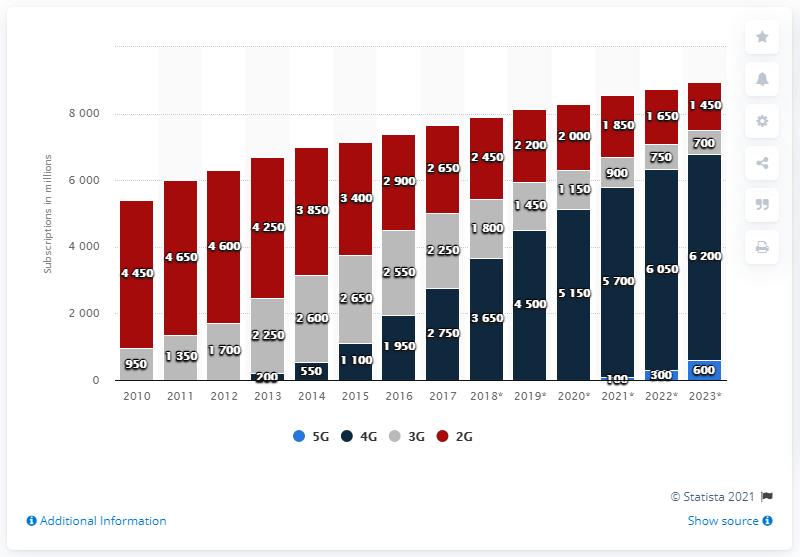Point out several critical features in this image. By 2020, it is projected that there will be approximately 51,500 wireless subscriptions in the United States. In 2017, there were 2,750 4G subscriptions. 